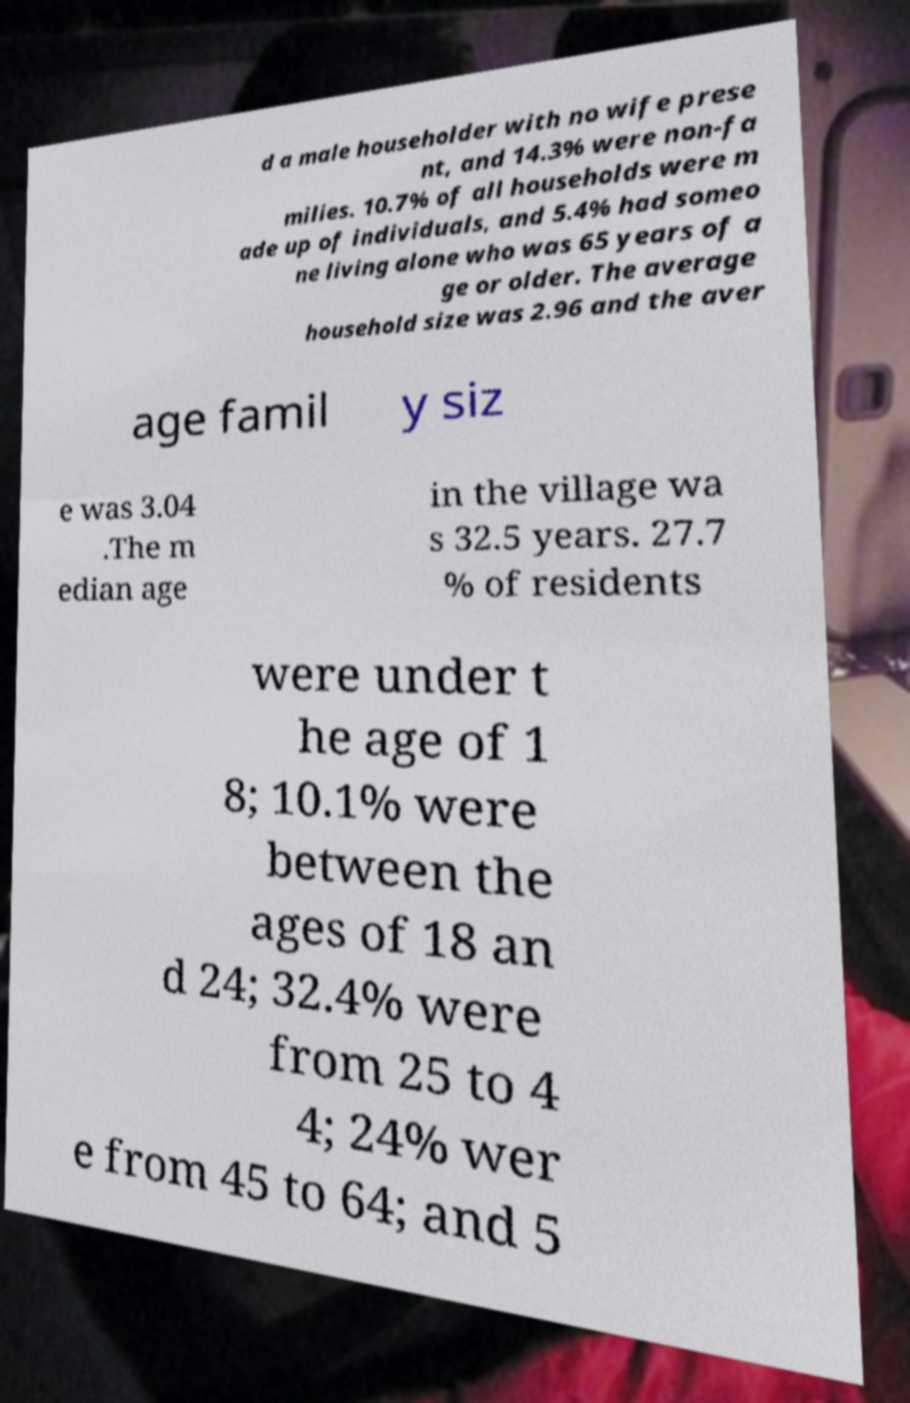Could you assist in decoding the text presented in this image and type it out clearly? d a male householder with no wife prese nt, and 14.3% were non-fa milies. 10.7% of all households were m ade up of individuals, and 5.4% had someo ne living alone who was 65 years of a ge or older. The average household size was 2.96 and the aver age famil y siz e was 3.04 .The m edian age in the village wa s 32.5 years. 27.7 % of residents were under t he age of 1 8; 10.1% were between the ages of 18 an d 24; 32.4% were from 25 to 4 4; 24% wer e from 45 to 64; and 5 